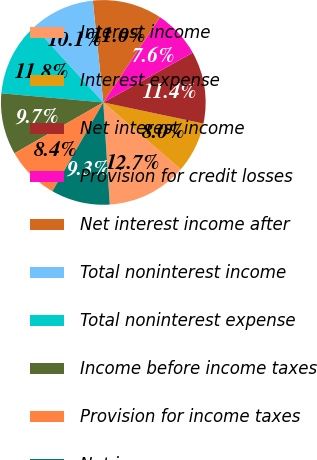Convert chart to OTSL. <chart><loc_0><loc_0><loc_500><loc_500><pie_chart><fcel>Interest income<fcel>Interest expense<fcel>Net interest income<fcel>Provision for credit losses<fcel>Net interest income after<fcel>Total noninterest income<fcel>Total noninterest expense<fcel>Income before income taxes<fcel>Provision for income taxes<fcel>Net income<nl><fcel>12.66%<fcel>8.02%<fcel>11.39%<fcel>7.59%<fcel>10.97%<fcel>10.13%<fcel>11.81%<fcel>9.7%<fcel>8.44%<fcel>9.28%<nl></chart> 